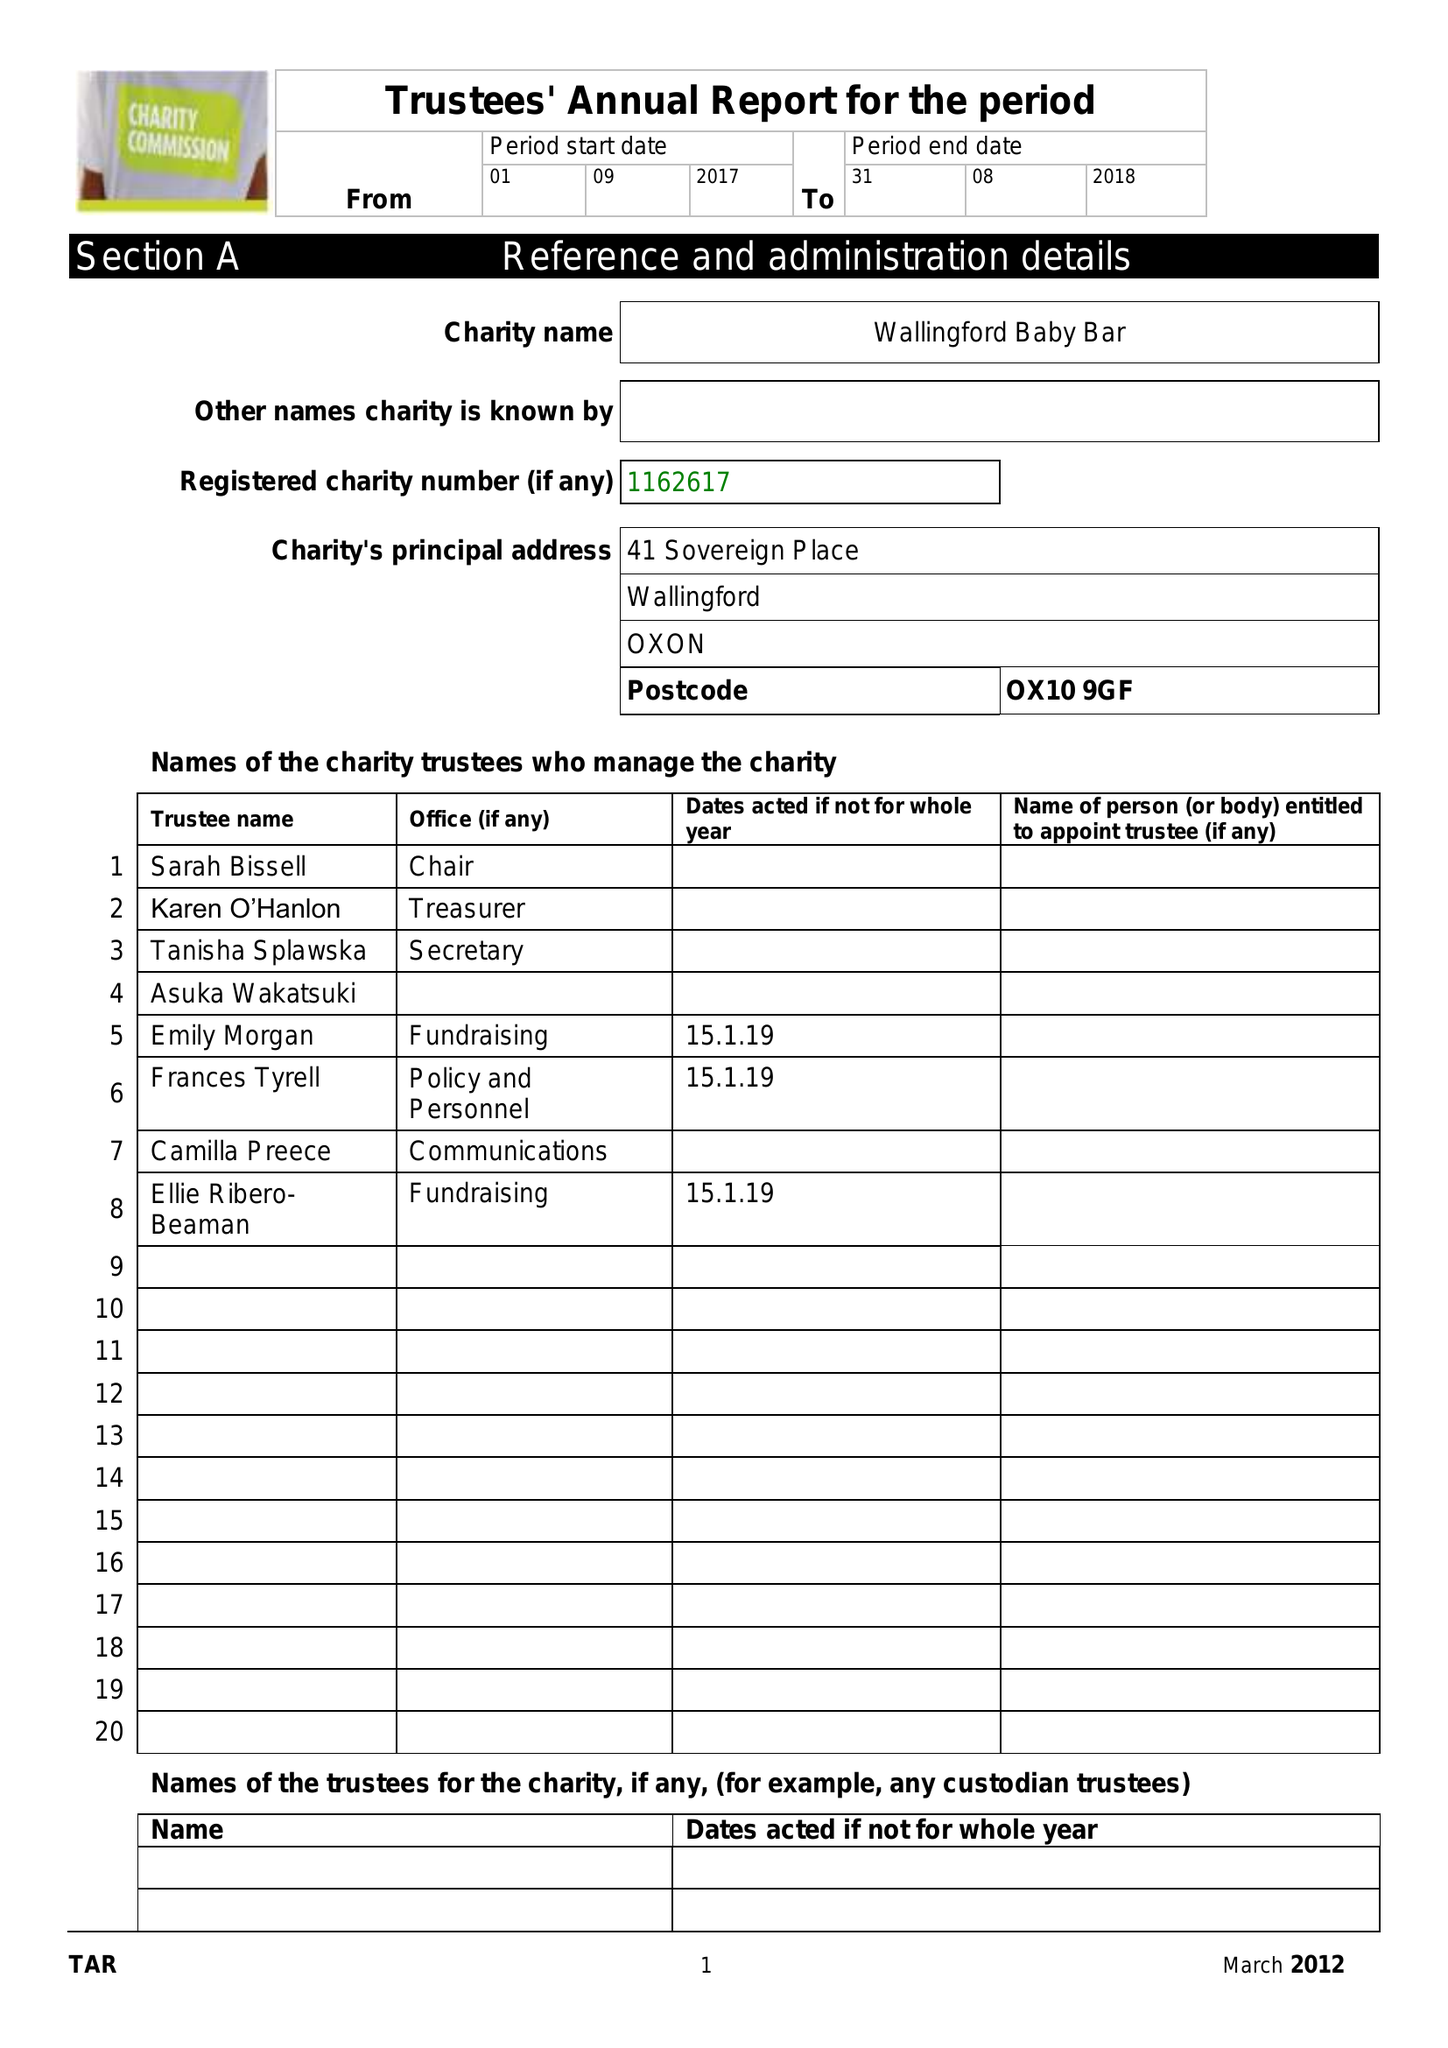What is the value for the address__post_town?
Answer the question using a single word or phrase. WALLINGFORD 